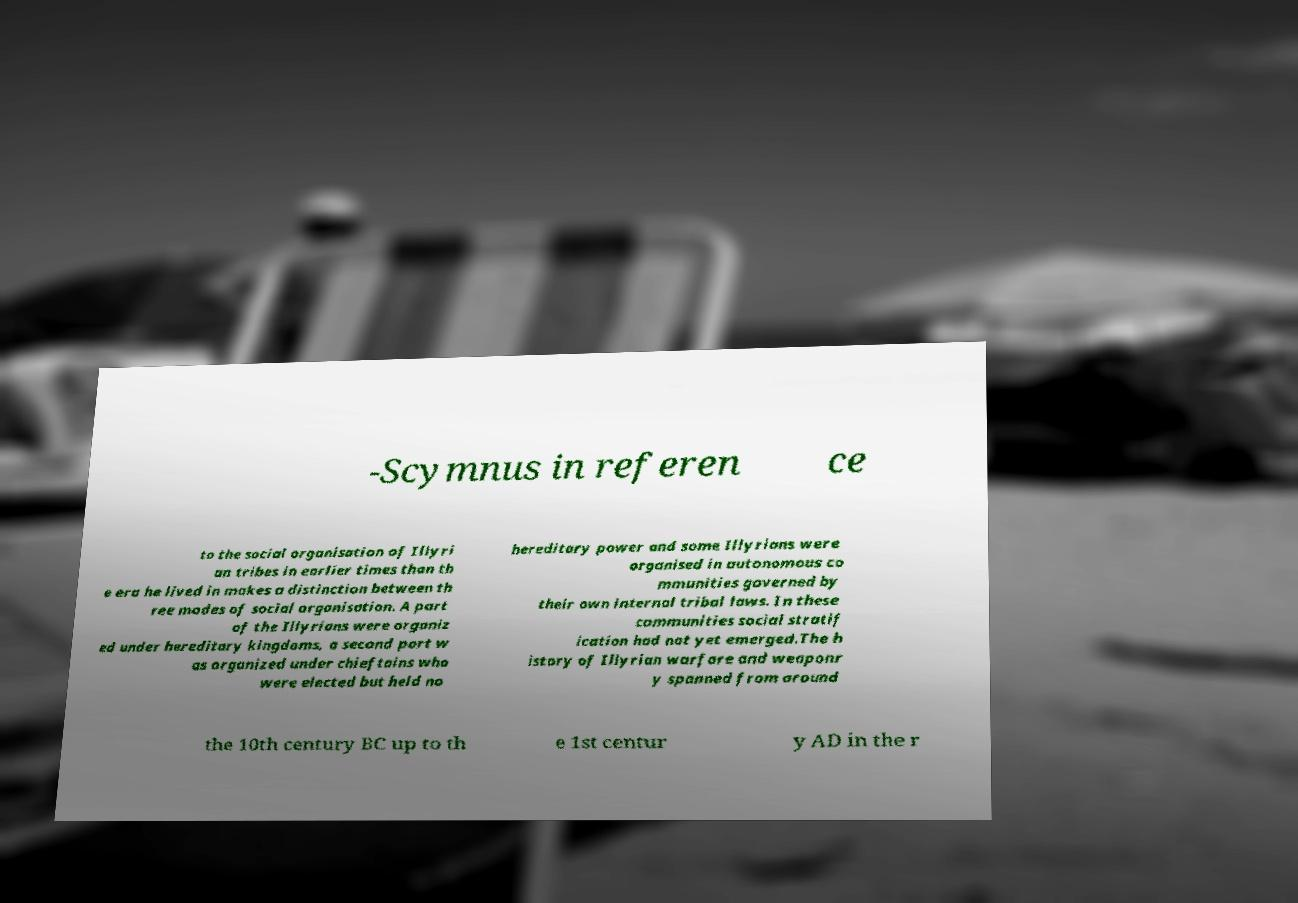Could you assist in decoding the text presented in this image and type it out clearly? -Scymnus in referen ce to the social organisation of Illyri an tribes in earlier times than th e era he lived in makes a distinction between th ree modes of social organisation. A part of the Illyrians were organiz ed under hereditary kingdoms, a second part w as organized under chieftains who were elected but held no hereditary power and some Illyrians were organised in autonomous co mmunities governed by their own internal tribal laws. In these communities social stratif ication had not yet emerged.The h istory of Illyrian warfare and weaponr y spanned from around the 10th century BC up to th e 1st centur y AD in the r 